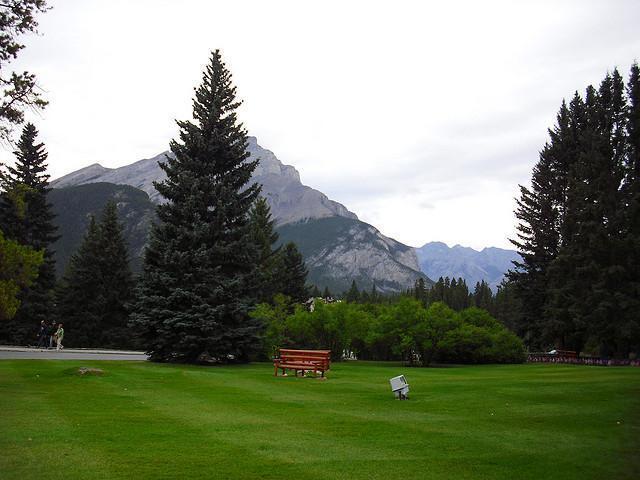How many benches are in the photo?
Give a very brief answer. 1. 